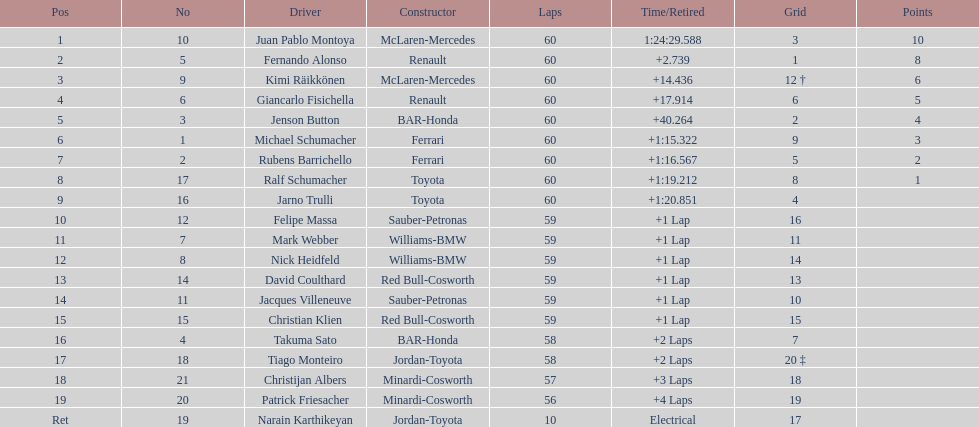Which motorist in the top 8, maneuvers a mclaren-mercedes but doesn't occupy the prime rank? Kimi Räikkönen. 